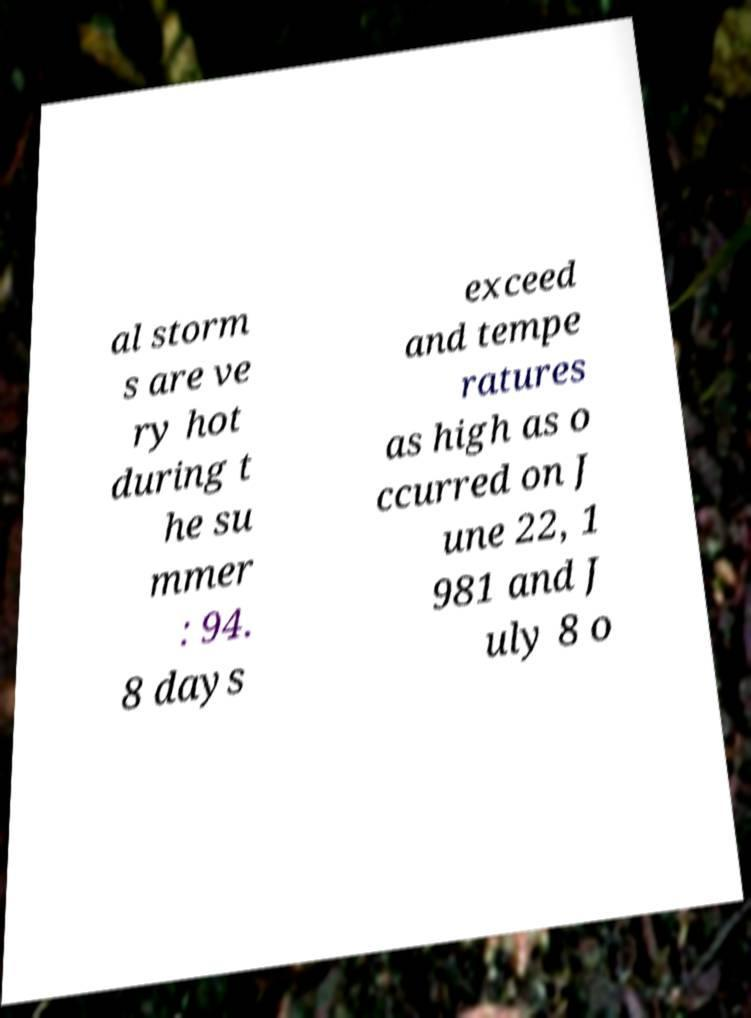Please identify and transcribe the text found in this image. al storm s are ve ry hot during t he su mmer : 94. 8 days exceed and tempe ratures as high as o ccurred on J une 22, 1 981 and J uly 8 o 